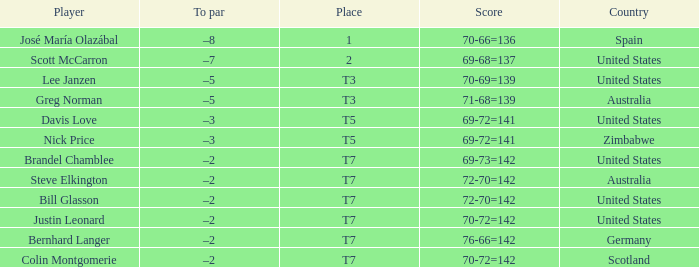Would you mind parsing the complete table? {'header': ['Player', 'To par', 'Place', 'Score', 'Country'], 'rows': [['José María Olazábal', '–8', '1', '70-66=136', 'Spain'], ['Scott McCarron', '–7', '2', '69-68=137', 'United States'], ['Lee Janzen', '–5', 'T3', '70-69=139', 'United States'], ['Greg Norman', '–5', 'T3', '71-68=139', 'Australia'], ['Davis Love', '–3', 'T5', '69-72=141', 'United States'], ['Nick Price', '–3', 'T5', '69-72=141', 'Zimbabwe'], ['Brandel Chamblee', '–2', 'T7', '69-73=142', 'United States'], ['Steve Elkington', '–2', 'T7', '72-70=142', 'Australia'], ['Bill Glasson', '–2', 'T7', '72-70=142', 'United States'], ['Justin Leonard', '–2', 'T7', '70-72=142', 'United States'], ['Bernhard Langer', '–2', 'T7', '76-66=142', 'Germany'], ['Colin Montgomerie', '–2', 'T7', '70-72=142', 'Scotland']]} Name the Player who has a To par of –2 and a Score of 69-73=142? Brandel Chamblee. 